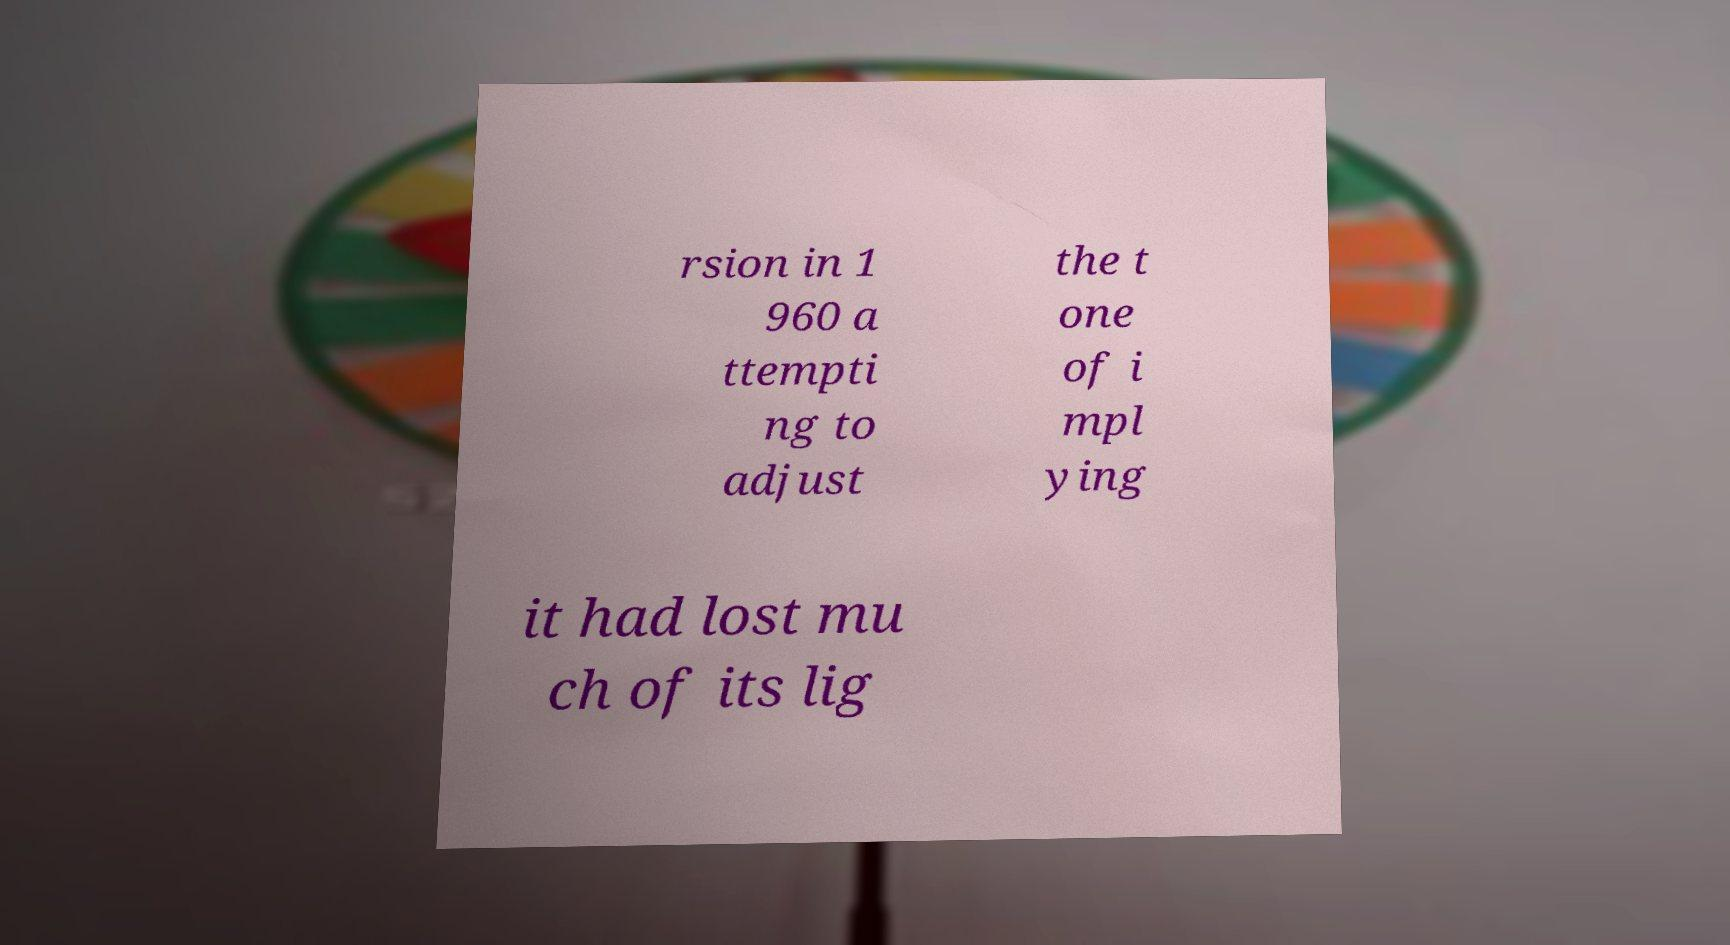What messages or text are displayed in this image? I need them in a readable, typed format. rsion in 1 960 a ttempti ng to adjust the t one of i mpl ying it had lost mu ch of its lig 